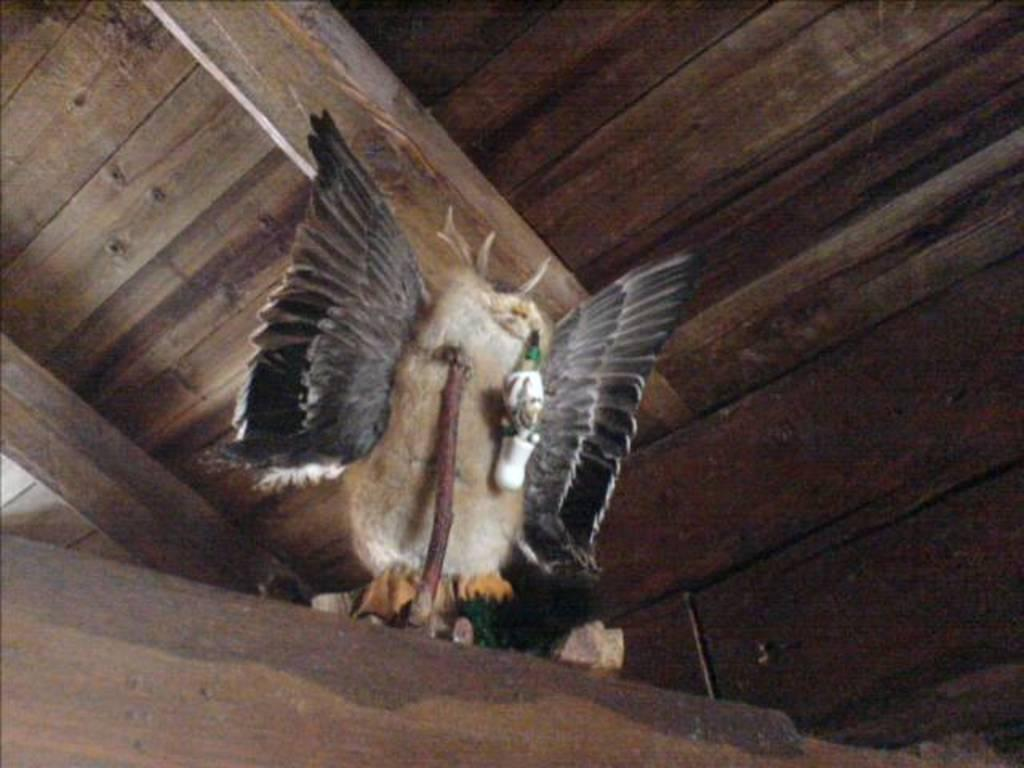What is the main subject in the center of the image? There is a doll in the center of the image. What type of surface is the doll placed on? The doll is on a wooden surface. What architectural feature can be seen in the image? There is a wooden roof visible in the image. How many kisses can be seen on the doll in the image? There are no kisses visible on the doll in the image. What type of thing is causing a shock in the image? There is no shock or thing causing a shock present in the image. 